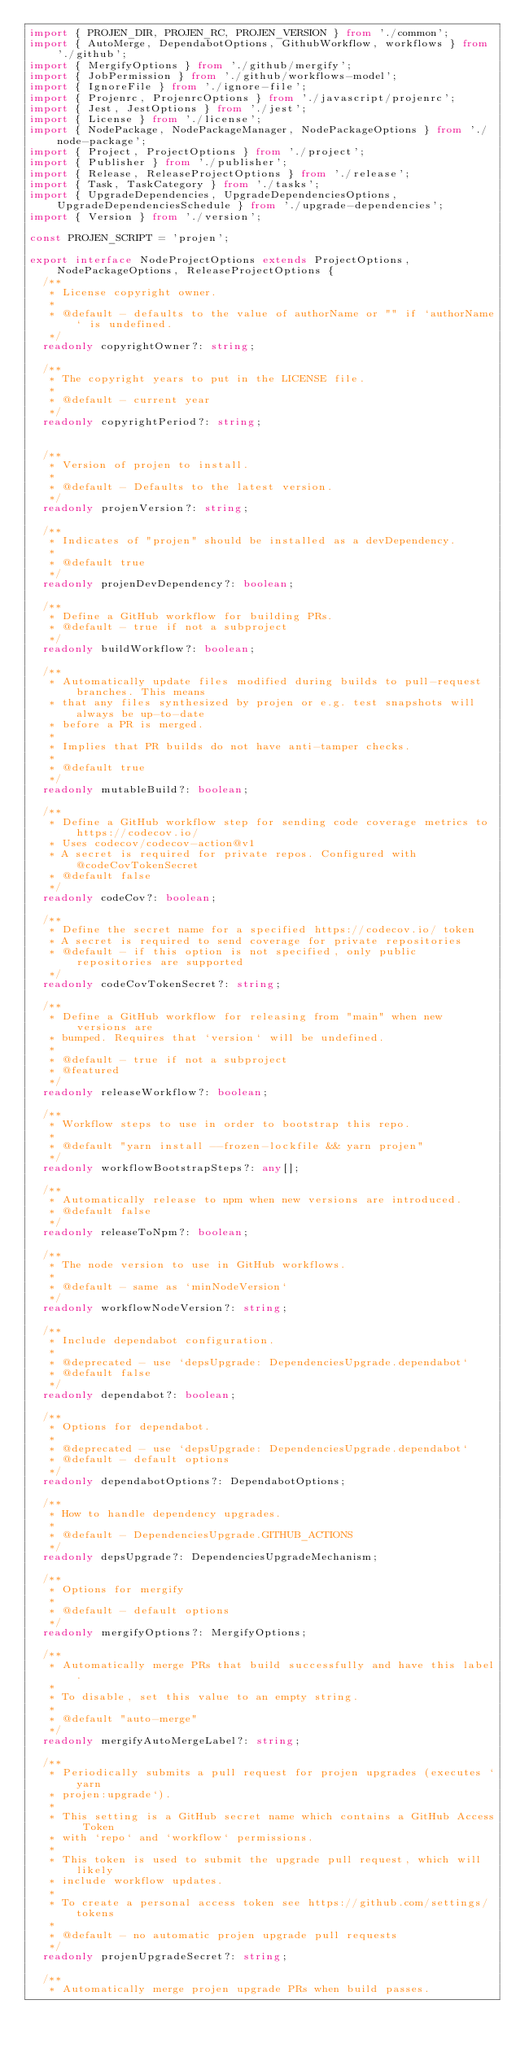Convert code to text. <code><loc_0><loc_0><loc_500><loc_500><_TypeScript_>import { PROJEN_DIR, PROJEN_RC, PROJEN_VERSION } from './common';
import { AutoMerge, DependabotOptions, GithubWorkflow, workflows } from './github';
import { MergifyOptions } from './github/mergify';
import { JobPermission } from './github/workflows-model';
import { IgnoreFile } from './ignore-file';
import { Projenrc, ProjenrcOptions } from './javascript/projenrc';
import { Jest, JestOptions } from './jest';
import { License } from './license';
import { NodePackage, NodePackageManager, NodePackageOptions } from './node-package';
import { Project, ProjectOptions } from './project';
import { Publisher } from './publisher';
import { Release, ReleaseProjectOptions } from './release';
import { Task, TaskCategory } from './tasks';
import { UpgradeDependencies, UpgradeDependenciesOptions, UpgradeDependenciesSchedule } from './upgrade-dependencies';
import { Version } from './version';

const PROJEN_SCRIPT = 'projen';

export interface NodeProjectOptions extends ProjectOptions, NodePackageOptions, ReleaseProjectOptions {
  /**
   * License copyright owner.
   *
   * @default - defaults to the value of authorName or "" if `authorName` is undefined.
   */
  readonly copyrightOwner?: string;

  /**
   * The copyright years to put in the LICENSE file.
   *
   * @default - current year
   */
  readonly copyrightPeriod?: string;


  /**
   * Version of projen to install.
   *
   * @default - Defaults to the latest version.
   */
  readonly projenVersion?: string;

  /**
   * Indicates of "projen" should be installed as a devDependency.
   *
   * @default true
   */
  readonly projenDevDependency?: boolean;

  /**
   * Define a GitHub workflow for building PRs.
   * @default - true if not a subproject
   */
  readonly buildWorkflow?: boolean;

  /**
   * Automatically update files modified during builds to pull-request branches. This means
   * that any files synthesized by projen or e.g. test snapshots will always be up-to-date
   * before a PR is merged.
   *
   * Implies that PR builds do not have anti-tamper checks.
   *
   * @default true
   */
  readonly mutableBuild?: boolean;

  /**
   * Define a GitHub workflow step for sending code coverage metrics to https://codecov.io/
   * Uses codecov/codecov-action@v1
   * A secret is required for private repos. Configured with @codeCovTokenSecret
   * @default false
   */
  readonly codeCov?: boolean;

  /**
   * Define the secret name for a specified https://codecov.io/ token
   * A secret is required to send coverage for private repositories
   * @default - if this option is not specified, only public repositories are supported
   */
  readonly codeCovTokenSecret?: string;

  /**
   * Define a GitHub workflow for releasing from "main" when new versions are
   * bumped. Requires that `version` will be undefined.
   *
   * @default - true if not a subproject
   * @featured
   */
  readonly releaseWorkflow?: boolean;

  /**
   * Workflow steps to use in order to bootstrap this repo.
   *
   * @default "yarn install --frozen-lockfile && yarn projen"
   */
  readonly workflowBootstrapSteps?: any[];

  /**
   * Automatically release to npm when new versions are introduced.
   * @default false
   */
  readonly releaseToNpm?: boolean;

  /**
   * The node version to use in GitHub workflows.
   *
   * @default - same as `minNodeVersion`
   */
  readonly workflowNodeVersion?: string;

  /**
   * Include dependabot configuration.
   *
   * @deprecated - use `depsUpgrade: DependenciesUpgrade.dependabot`
   * @default false
   */
  readonly dependabot?: boolean;

  /**
   * Options for dependabot.
   *
   * @deprecated - use `depsUpgrade: DependenciesUpgrade.dependabot`
   * @default - default options
   */
  readonly dependabotOptions?: DependabotOptions;

  /**
   * How to handle dependency upgrades.
   *
   * @default - DependenciesUpgrade.GITHUB_ACTIONS
   */
  readonly depsUpgrade?: DependenciesUpgradeMechanism;

  /**
   * Options for mergify
   *
   * @default - default options
   */
  readonly mergifyOptions?: MergifyOptions;

  /**
   * Automatically merge PRs that build successfully and have this label.
   *
   * To disable, set this value to an empty string.
   *
   * @default "auto-merge"
   */
  readonly mergifyAutoMergeLabel?: string;

  /**
   * Periodically submits a pull request for projen upgrades (executes `yarn
   * projen:upgrade`).
   *
   * This setting is a GitHub secret name which contains a GitHub Access Token
   * with `repo` and `workflow` permissions.
   *
   * This token is used to submit the upgrade pull request, which will likely
   * include workflow updates.
   *
   * To create a personal access token see https://github.com/settings/tokens
   *
   * @default - no automatic projen upgrade pull requests
   */
  readonly projenUpgradeSecret?: string;

  /**
   * Automatically merge projen upgrade PRs when build passes.</code> 